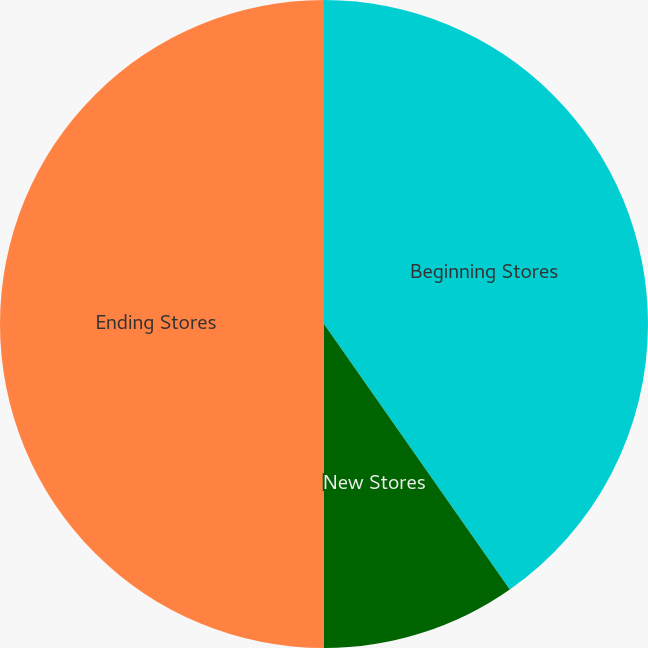<chart> <loc_0><loc_0><loc_500><loc_500><pie_chart><fcel>Beginning Stores<fcel>New Stores<fcel>Ending Stores<nl><fcel>40.28%<fcel>9.72%<fcel>50.0%<nl></chart> 